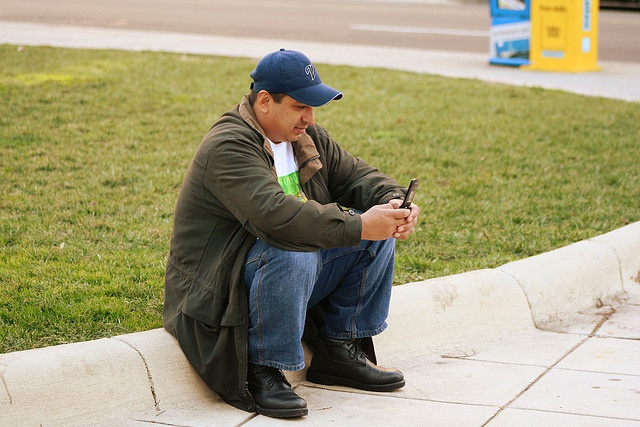Describe the objects in this image and their specific colors. I can see people in tan, black, and gray tones and cell phone in tan, black, and gray tones in this image. 